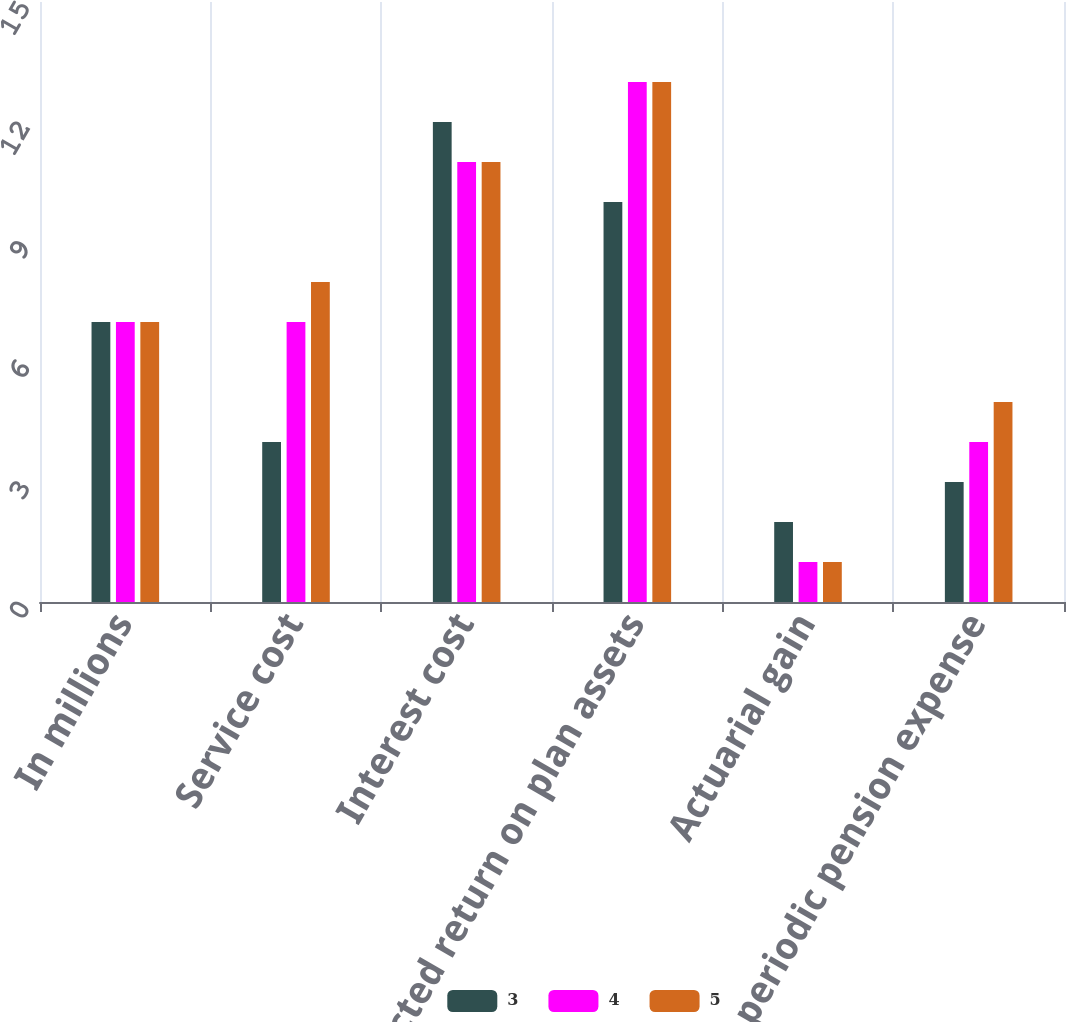Convert chart to OTSL. <chart><loc_0><loc_0><loc_500><loc_500><stacked_bar_chart><ecel><fcel>In millions<fcel>Service cost<fcel>Interest cost<fcel>Expected return on plan assets<fcel>Actuarial gain<fcel>Net periodic pension expense<nl><fcel>3<fcel>7<fcel>4<fcel>12<fcel>10<fcel>2<fcel>3<nl><fcel>4<fcel>7<fcel>7<fcel>11<fcel>13<fcel>1<fcel>4<nl><fcel>5<fcel>7<fcel>8<fcel>11<fcel>13<fcel>1<fcel>5<nl></chart> 